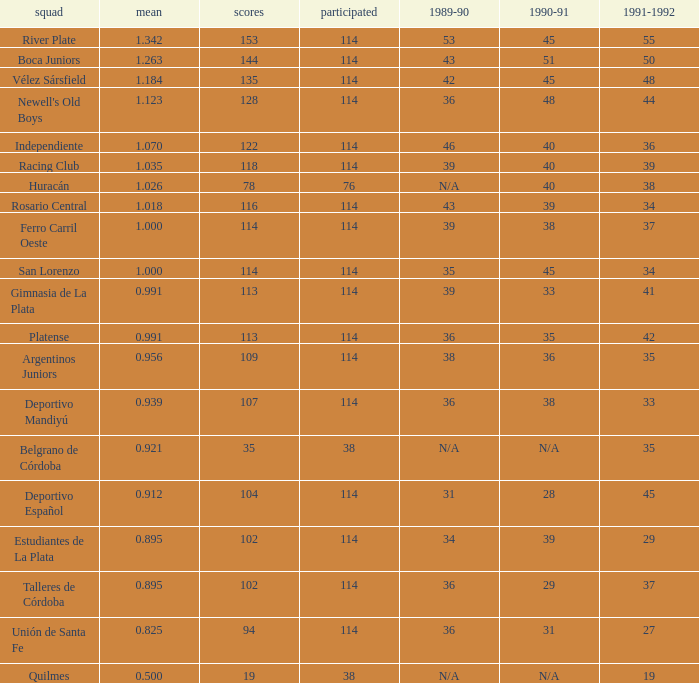How much Played has an Average smaller than 0.9390000000000001, and a 1990-91 of 28? 1.0. 